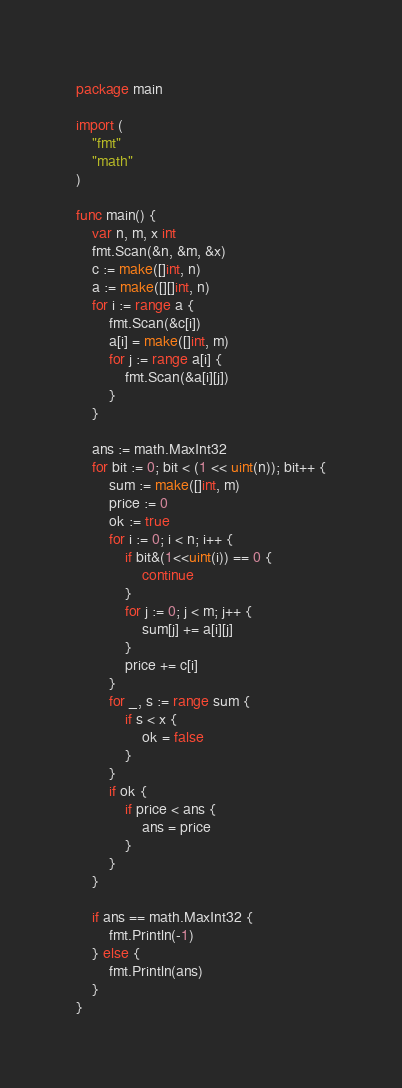Convert code to text. <code><loc_0><loc_0><loc_500><loc_500><_Go_>package main

import (
	"fmt"
	"math"
)

func main() {
	var n, m, x int
	fmt.Scan(&n, &m, &x)
	c := make([]int, n)
	a := make([][]int, n)
	for i := range a {
		fmt.Scan(&c[i])
		a[i] = make([]int, m)
		for j := range a[i] {
			fmt.Scan(&a[i][j])
		}
	}

	ans := math.MaxInt32
	for bit := 0; bit < (1 << uint(n)); bit++ {
		sum := make([]int, m)
		price := 0
		ok := true
		for i := 0; i < n; i++ {
			if bit&(1<<uint(i)) == 0 {
				continue
			}
			for j := 0; j < m; j++ {
				sum[j] += a[i][j]
			}
			price += c[i]
		}
		for _, s := range sum {
			if s < x {
				ok = false
			}
		}
		if ok {
			if price < ans {
				ans = price
			}
		}
	}

	if ans == math.MaxInt32 {
		fmt.Println(-1)
	} else {
		fmt.Println(ans)
	}
}
</code> 